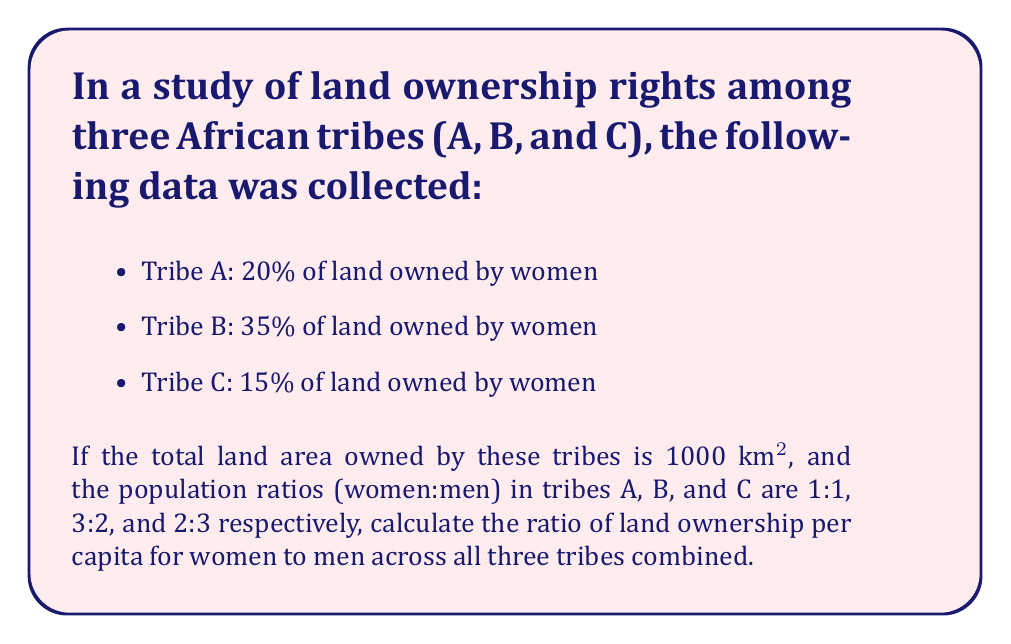Teach me how to tackle this problem. 1. Calculate the land owned by women and men in each tribe:
   Tribe A: Women - 20% of (1000/3) = 66.67 km²; Men - 266.67 km²
   Tribe B: Women - 35% of (1000/3) = 116.67 km²; Men - 216.67 km²
   Tribe C: Women - 15% of (1000/3) = 50 km²; Men - 283.33 km²

2. Calculate the total land owned by women and men:
   Women: 66.67 + 116.67 + 50 = 233.34 km²
   Men: 266.67 + 216.67 + 283.33 = 766.67 km²

3. Calculate the total population of women and men:
   Tribe A: Women - 1, Men - 1 (ratio 1:1)
   Tribe B: Women - 3, Men - 2 (ratio 3:2)
   Tribe C: Women - 2, Men - 3 (ratio 2:3)
   Total: Women - 6, Men - 6

4. Calculate land ownership per capita:
   Women: $\frac{233.34}{6} = 38.89$ km²/person
   Men: $\frac{766.67}{6} = 127.78$ km²/person

5. Calculate the ratio of land ownership per capita (women to men):
   $\frac{38.89}{127.78} = \frac{1}{3.285} \approx 0.3043$
Answer: $1:3.285$ or approximately $0.3043:1$ 